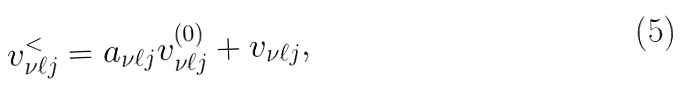Convert formula to latex. <formula><loc_0><loc_0><loc_500><loc_500>v _ { \nu { \ell } j } ^ { < } = a _ { \nu { \ell } j } v _ { \nu { \ell } j } ^ { ( 0 ) } + v _ { \nu { \ell } j } ,</formula> 